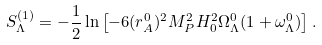Convert formula to latex. <formula><loc_0><loc_0><loc_500><loc_500>S _ { \Lambda } ^ { ( 1 ) } = - \frac { 1 } { 2 } \ln \left [ - 6 ( r _ { A } ^ { 0 } ) ^ { 2 } M _ { P } ^ { 2 } H _ { 0 } ^ { 2 } \Omega _ { \Lambda } ^ { 0 } ( 1 + \omega _ { \Lambda } ^ { 0 } ) \right ] .</formula> 